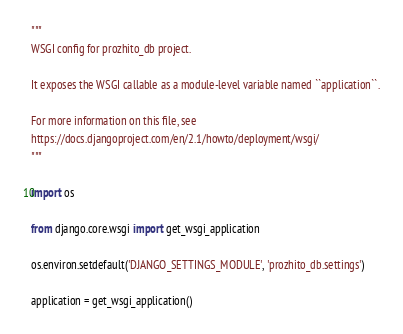<code> <loc_0><loc_0><loc_500><loc_500><_Python_>"""
WSGI config for prozhito_db project.

It exposes the WSGI callable as a module-level variable named ``application``.

For more information on this file, see
https://docs.djangoproject.com/en/2.1/howto/deployment/wsgi/
"""

import os

from django.core.wsgi import get_wsgi_application

os.environ.setdefault('DJANGO_SETTINGS_MODULE', 'prozhito_db.settings')

application = get_wsgi_application()
</code> 